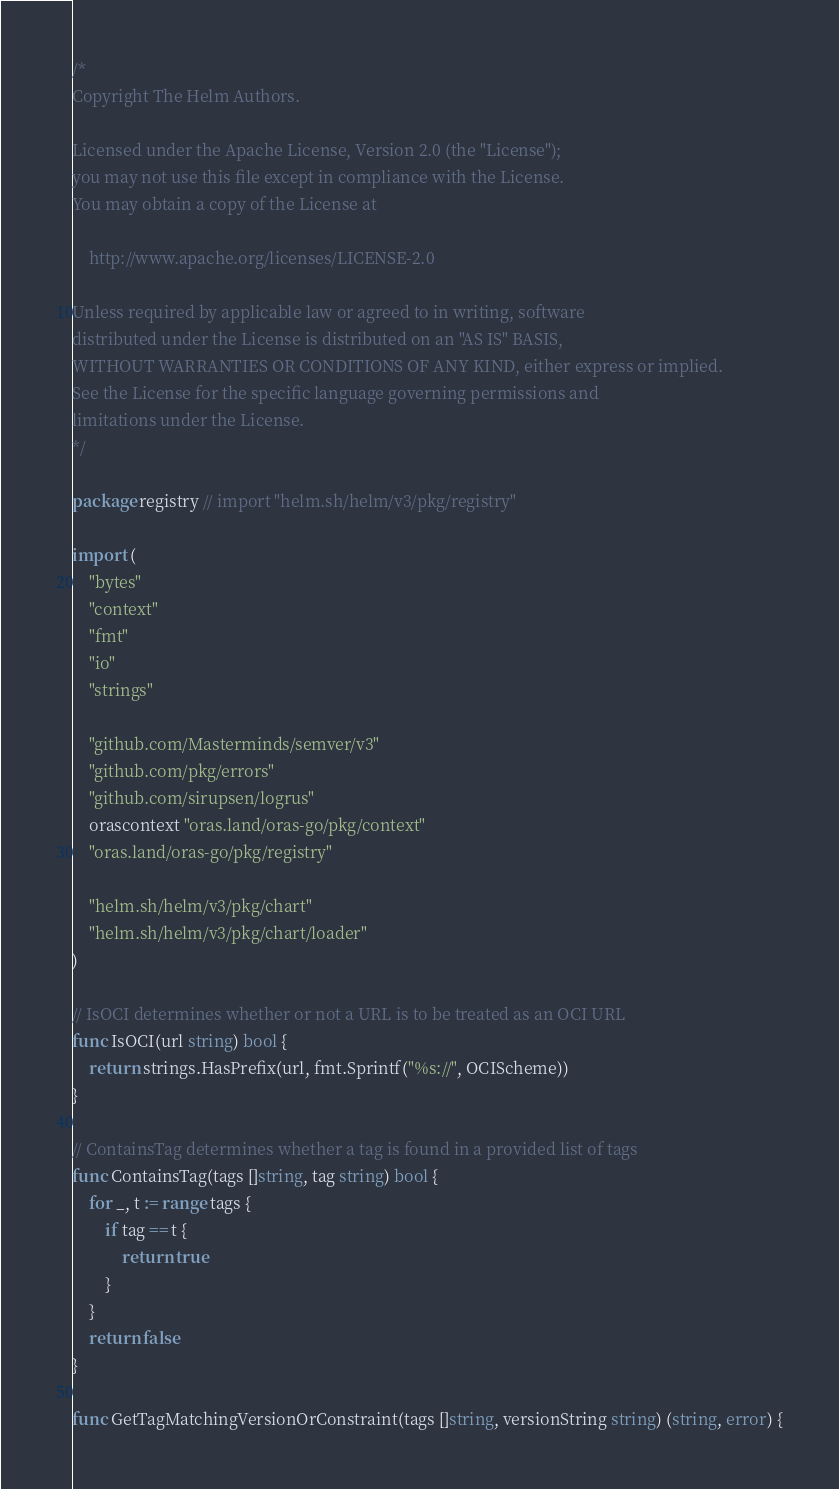<code> <loc_0><loc_0><loc_500><loc_500><_Go_>/*
Copyright The Helm Authors.

Licensed under the Apache License, Version 2.0 (the "License");
you may not use this file except in compliance with the License.
You may obtain a copy of the License at

    http://www.apache.org/licenses/LICENSE-2.0

Unless required by applicable law or agreed to in writing, software
distributed under the License is distributed on an "AS IS" BASIS,
WITHOUT WARRANTIES OR CONDITIONS OF ANY KIND, either express or implied.
See the License for the specific language governing permissions and
limitations under the License.
*/

package registry // import "helm.sh/helm/v3/pkg/registry"

import (
	"bytes"
	"context"
	"fmt"
	"io"
	"strings"

	"github.com/Masterminds/semver/v3"
	"github.com/pkg/errors"
	"github.com/sirupsen/logrus"
	orascontext "oras.land/oras-go/pkg/context"
	"oras.land/oras-go/pkg/registry"

	"helm.sh/helm/v3/pkg/chart"
	"helm.sh/helm/v3/pkg/chart/loader"
)

// IsOCI determines whether or not a URL is to be treated as an OCI URL
func IsOCI(url string) bool {
	return strings.HasPrefix(url, fmt.Sprintf("%s://", OCIScheme))
}

// ContainsTag determines whether a tag is found in a provided list of tags
func ContainsTag(tags []string, tag string) bool {
	for _, t := range tags {
		if tag == t {
			return true
		}
	}
	return false
}

func GetTagMatchingVersionOrConstraint(tags []string, versionString string) (string, error) {</code> 